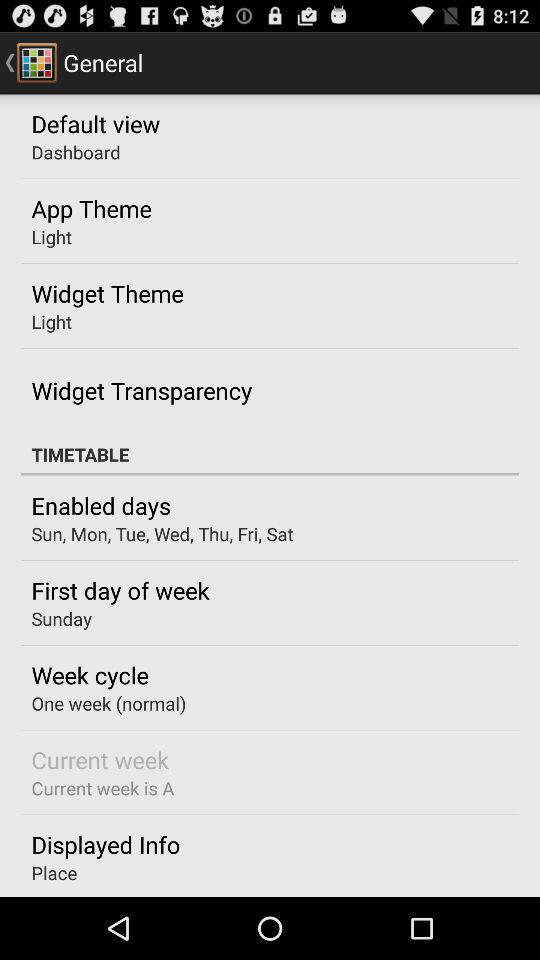What are the enabled days? The enabled days are Sunday, Monday, Tuesday, Wednesday, Thursday, Friday, and Saturday. 